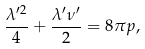Convert formula to latex. <formula><loc_0><loc_0><loc_500><loc_500>\frac { \lambda ^ { \prime 2 } } 4 + \frac { \lambda ^ { \prime } \nu ^ { \prime } } 2 = 8 \pi p ,</formula> 